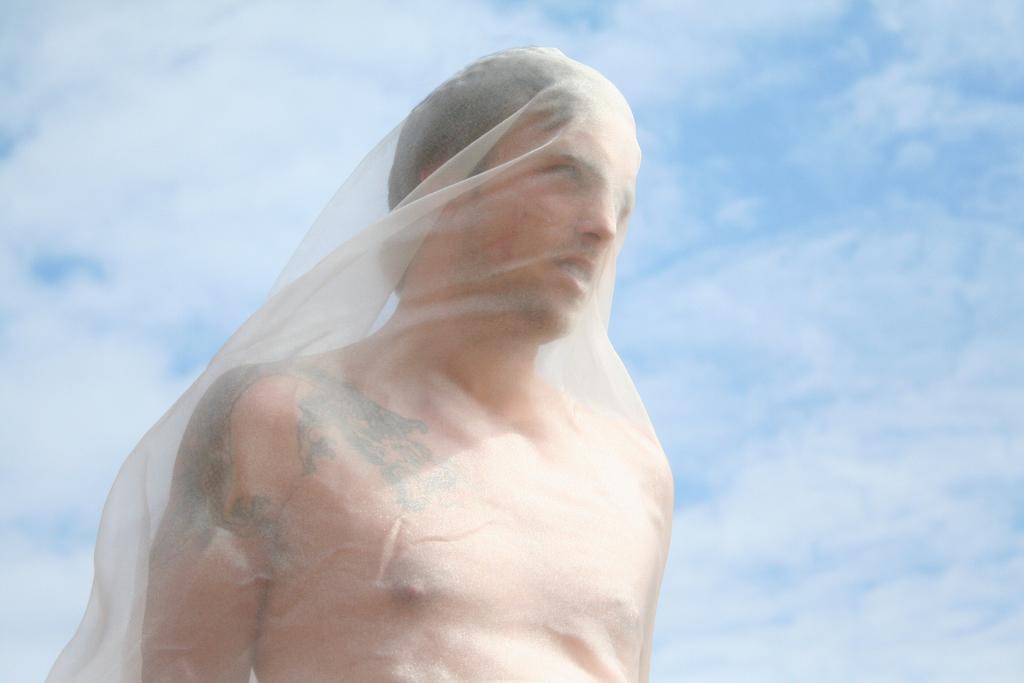Describe this image in one or two sentences. In this picture we can see a man, and we can find a cloth on him, in the background we can see clouds. 